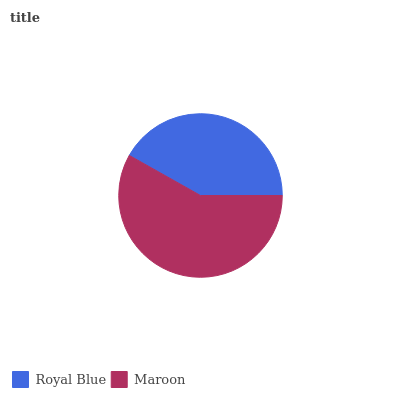Is Royal Blue the minimum?
Answer yes or no. Yes. Is Maroon the maximum?
Answer yes or no. Yes. Is Maroon the minimum?
Answer yes or no. No. Is Maroon greater than Royal Blue?
Answer yes or no. Yes. Is Royal Blue less than Maroon?
Answer yes or no. Yes. Is Royal Blue greater than Maroon?
Answer yes or no. No. Is Maroon less than Royal Blue?
Answer yes or no. No. Is Maroon the high median?
Answer yes or no. Yes. Is Royal Blue the low median?
Answer yes or no. Yes. Is Royal Blue the high median?
Answer yes or no. No. Is Maroon the low median?
Answer yes or no. No. 